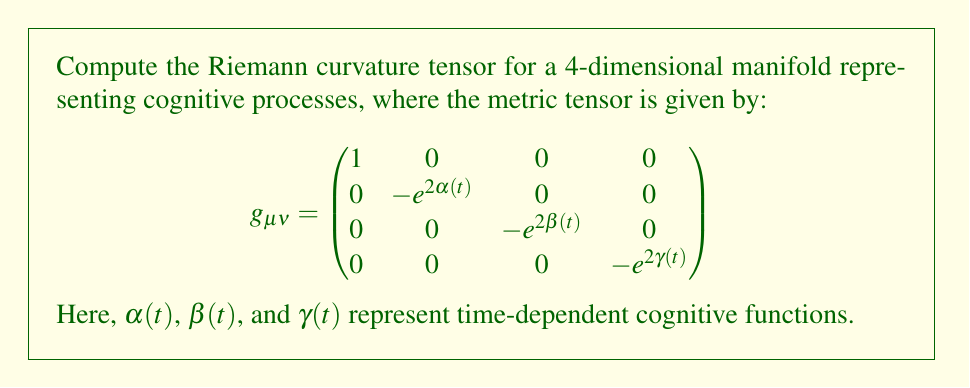Help me with this question. To compute the Riemann curvature tensor, we'll follow these steps:

1) First, calculate the Christoffel symbols using:
   $$\Gamma^\lambda_{\mu\nu} = \frac{1}{2}g^{\lambda\sigma}(\partial_\mu g_{\nu\sigma} + \partial_\nu g_{\mu\sigma} - \partial_\sigma g_{\mu\nu})$$

2) The non-zero Christoffel symbols are:
   $$\Gamma^1_{11} = \dot{\alpha}, \Gamma^1_{22} = \dot{\beta}, \Gamma^1_{33} = \dot{\gamma}$$
   $$\Gamma^2_{12} = \Gamma^2_{21} = \dot{\alpha}, \Gamma^3_{13} = \Gamma^3_{31} = \dot{\beta}, \Gamma^4_{14} = \Gamma^4_{41} = \dot{\gamma}$$

3) Now, use the Riemann tensor formula:
   $$R^\rho_{\sigma\mu\nu} = \partial_\mu \Gamma^\rho_{\nu\sigma} - \partial_\nu \Gamma^\rho_{\mu\sigma} + \Gamma^\rho_{\mu\lambda}\Gamma^\lambda_{\nu\sigma} - \Gamma^\rho_{\nu\lambda}\Gamma^\lambda_{\mu\sigma}$$

4) Calculate the non-zero components:
   $$R^1_{212} = -e^{2\alpha}(\ddot{\alpha} + \dot{\alpha}^2)$$
   $$R^1_{313} = -e^{2\beta}(\ddot{\beta} + \dot{\beta}^2)$$
   $$R^1_{414} = -e^{2\gamma}(\ddot{\gamma} + \dot{\gamma}^2)$$
   $$R^2_{323} = -e^{2(\beta-\alpha)}\dot{\alpha}\dot{\beta}$$
   $$R^2_{424} = -e^{2(\gamma-\alpha)}\dot{\alpha}\dot{\gamma}$$
   $$R^3_{434} = -e^{2(\gamma-\beta)}\dot{\beta}\dot{\gamma}$$

5) The remaining components can be obtained by symmetry and antisymmetry properties of the Riemann tensor.

This tensor represents the curvature of the cognitive process manifold, where each component describes how different cognitive functions interact and evolve over time.
Answer: $R^1_{212} = -e^{2\alpha}(\ddot{\alpha} + \dot{\alpha}^2)$, $R^1_{313} = -e^{2\beta}(\ddot{\beta} + \dot{\beta}^2)$, $R^1_{414} = -e^{2\gamma}(\ddot{\gamma} + \dot{\gamma}^2)$, $R^2_{323} = -e^{2(\beta-\alpha)}\dot{\alpha}\dot{\beta}$, $R^2_{424} = -e^{2(\gamma-\alpha)}\dot{\alpha}\dot{\gamma}$, $R^3_{434} = -e^{2(\gamma-\beta)}\dot{\beta}\dot{\gamma}$, and their symmetric/antisymmetric counterparts. 